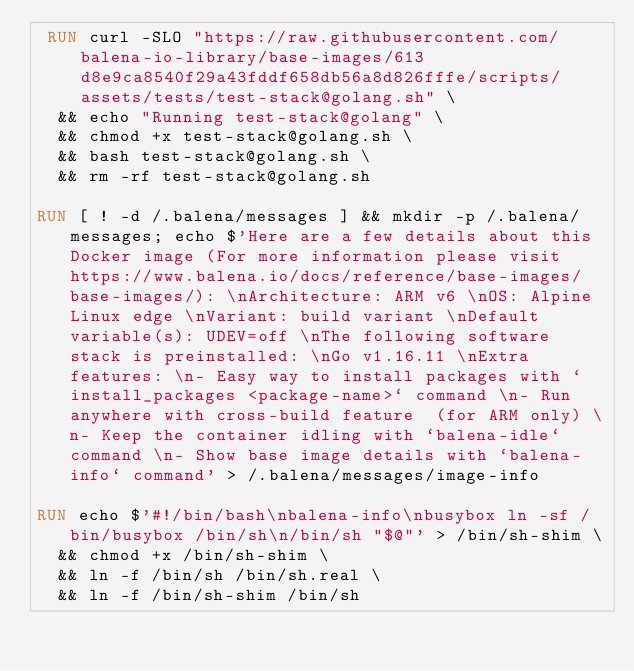<code> <loc_0><loc_0><loc_500><loc_500><_Dockerfile_> RUN curl -SLO "https://raw.githubusercontent.com/balena-io-library/base-images/613d8e9ca8540f29a43fddf658db56a8d826fffe/scripts/assets/tests/test-stack@golang.sh" \
  && echo "Running test-stack@golang" \
  && chmod +x test-stack@golang.sh \
  && bash test-stack@golang.sh \
  && rm -rf test-stack@golang.sh 

RUN [ ! -d /.balena/messages ] && mkdir -p /.balena/messages; echo $'Here are a few details about this Docker image (For more information please visit https://www.balena.io/docs/reference/base-images/base-images/): \nArchitecture: ARM v6 \nOS: Alpine Linux edge \nVariant: build variant \nDefault variable(s): UDEV=off \nThe following software stack is preinstalled: \nGo v1.16.11 \nExtra features: \n- Easy way to install packages with `install_packages <package-name>` command \n- Run anywhere with cross-build feature  (for ARM only) \n- Keep the container idling with `balena-idle` command \n- Show base image details with `balena-info` command' > /.balena/messages/image-info

RUN echo $'#!/bin/bash\nbalena-info\nbusybox ln -sf /bin/busybox /bin/sh\n/bin/sh "$@"' > /bin/sh-shim \
	&& chmod +x /bin/sh-shim \
	&& ln -f /bin/sh /bin/sh.real \
	&& ln -f /bin/sh-shim /bin/sh</code> 